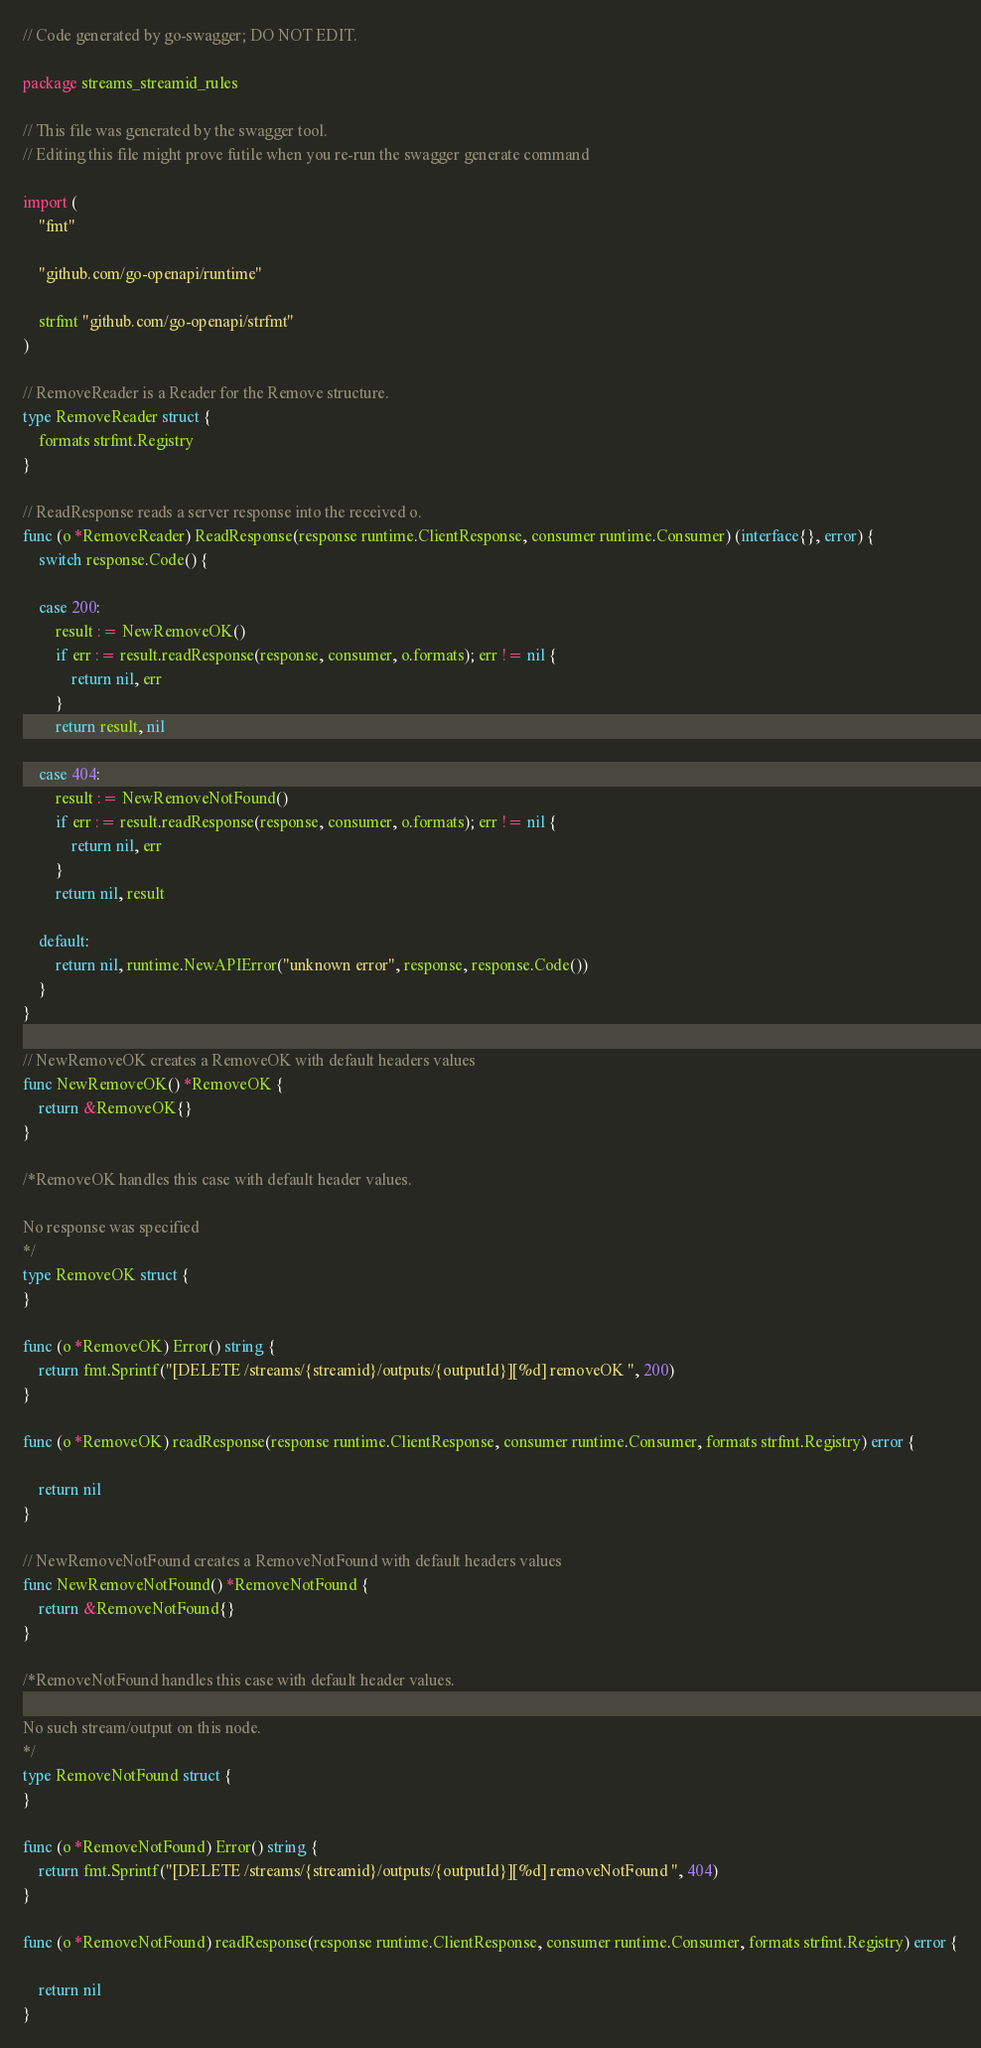<code> <loc_0><loc_0><loc_500><loc_500><_Go_>// Code generated by go-swagger; DO NOT EDIT.

package streams_streamid_rules

// This file was generated by the swagger tool.
// Editing this file might prove futile when you re-run the swagger generate command

import (
	"fmt"

	"github.com/go-openapi/runtime"

	strfmt "github.com/go-openapi/strfmt"
)

// RemoveReader is a Reader for the Remove structure.
type RemoveReader struct {
	formats strfmt.Registry
}

// ReadResponse reads a server response into the received o.
func (o *RemoveReader) ReadResponse(response runtime.ClientResponse, consumer runtime.Consumer) (interface{}, error) {
	switch response.Code() {

	case 200:
		result := NewRemoveOK()
		if err := result.readResponse(response, consumer, o.formats); err != nil {
			return nil, err
		}
		return result, nil

	case 404:
		result := NewRemoveNotFound()
		if err := result.readResponse(response, consumer, o.formats); err != nil {
			return nil, err
		}
		return nil, result

	default:
		return nil, runtime.NewAPIError("unknown error", response, response.Code())
	}
}

// NewRemoveOK creates a RemoveOK with default headers values
func NewRemoveOK() *RemoveOK {
	return &RemoveOK{}
}

/*RemoveOK handles this case with default header values.

No response was specified
*/
type RemoveOK struct {
}

func (o *RemoveOK) Error() string {
	return fmt.Sprintf("[DELETE /streams/{streamid}/outputs/{outputId}][%d] removeOK ", 200)
}

func (o *RemoveOK) readResponse(response runtime.ClientResponse, consumer runtime.Consumer, formats strfmt.Registry) error {

	return nil
}

// NewRemoveNotFound creates a RemoveNotFound with default headers values
func NewRemoveNotFound() *RemoveNotFound {
	return &RemoveNotFound{}
}

/*RemoveNotFound handles this case with default header values.

No such stream/output on this node.
*/
type RemoveNotFound struct {
}

func (o *RemoveNotFound) Error() string {
	return fmt.Sprintf("[DELETE /streams/{streamid}/outputs/{outputId}][%d] removeNotFound ", 404)
}

func (o *RemoveNotFound) readResponse(response runtime.ClientResponse, consumer runtime.Consumer, formats strfmt.Registry) error {

	return nil
}
</code> 